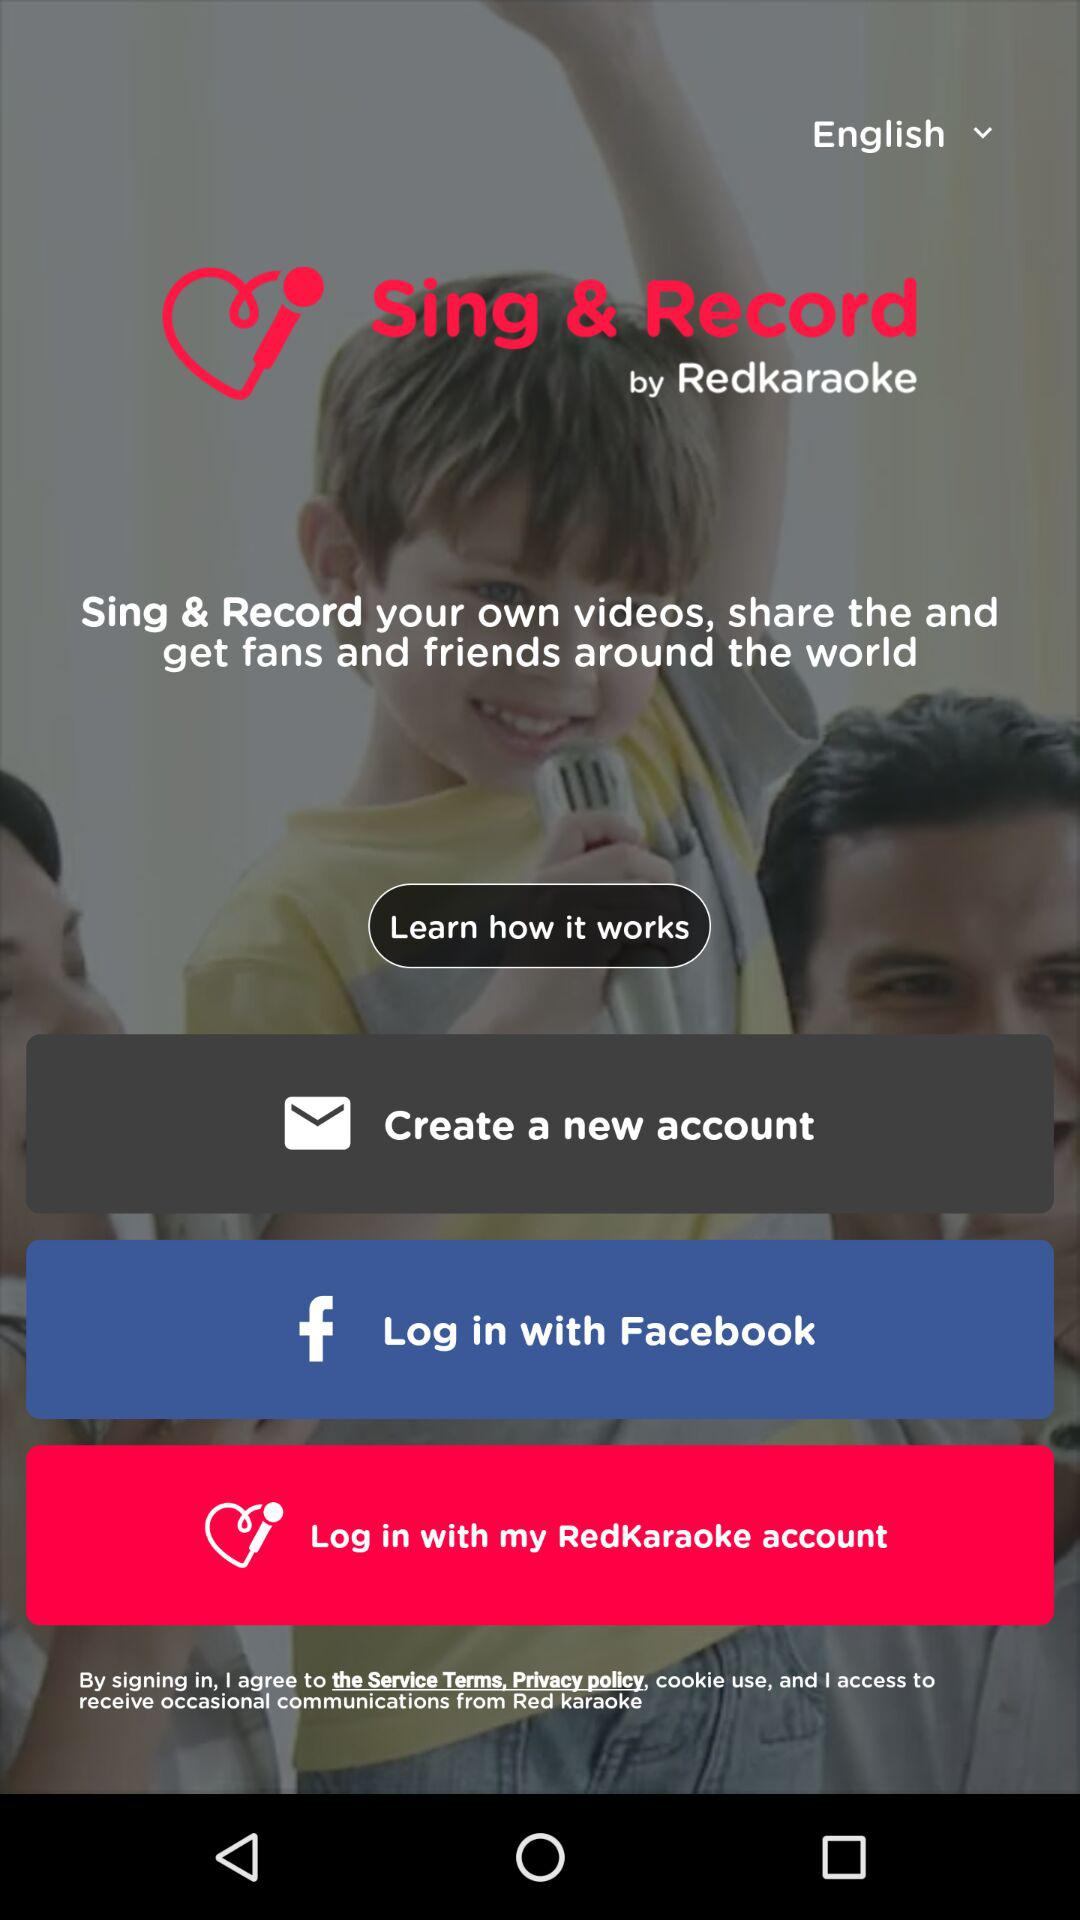What are the options for log in? You can log in with "Facebook" and "RedKaraoke". 